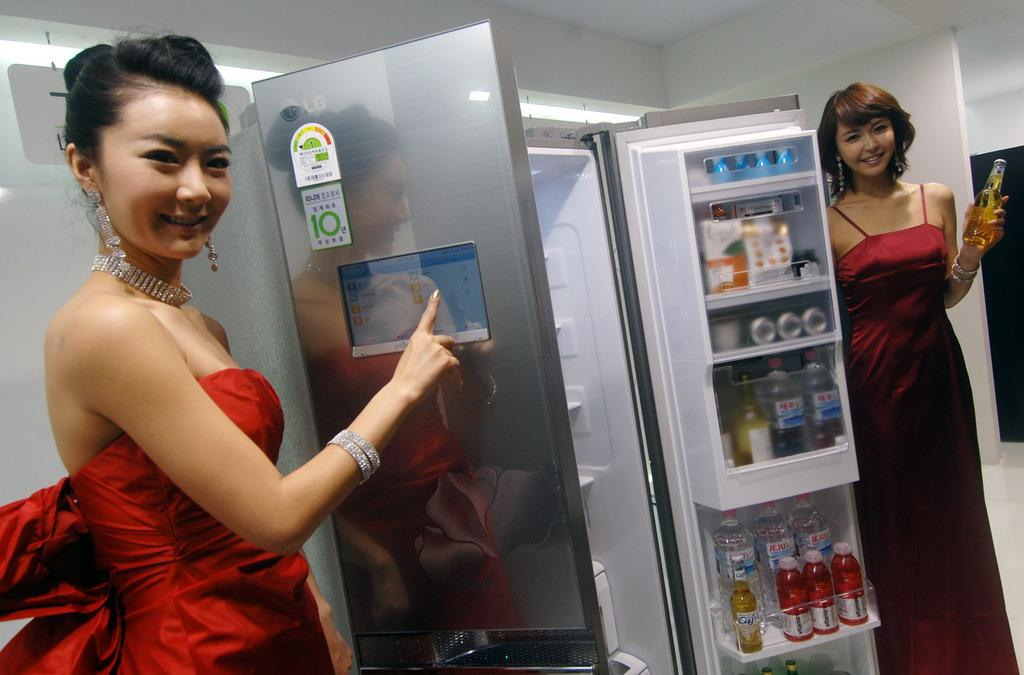<image>
Give a short and clear explanation of the subsequent image. Two women are showing off an LG brand refrigerator. 